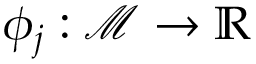<formula> <loc_0><loc_0><loc_500><loc_500>\phi _ { j } \colon \ m a t h s c r { M } \rightarrow \mathbb { R }</formula> 